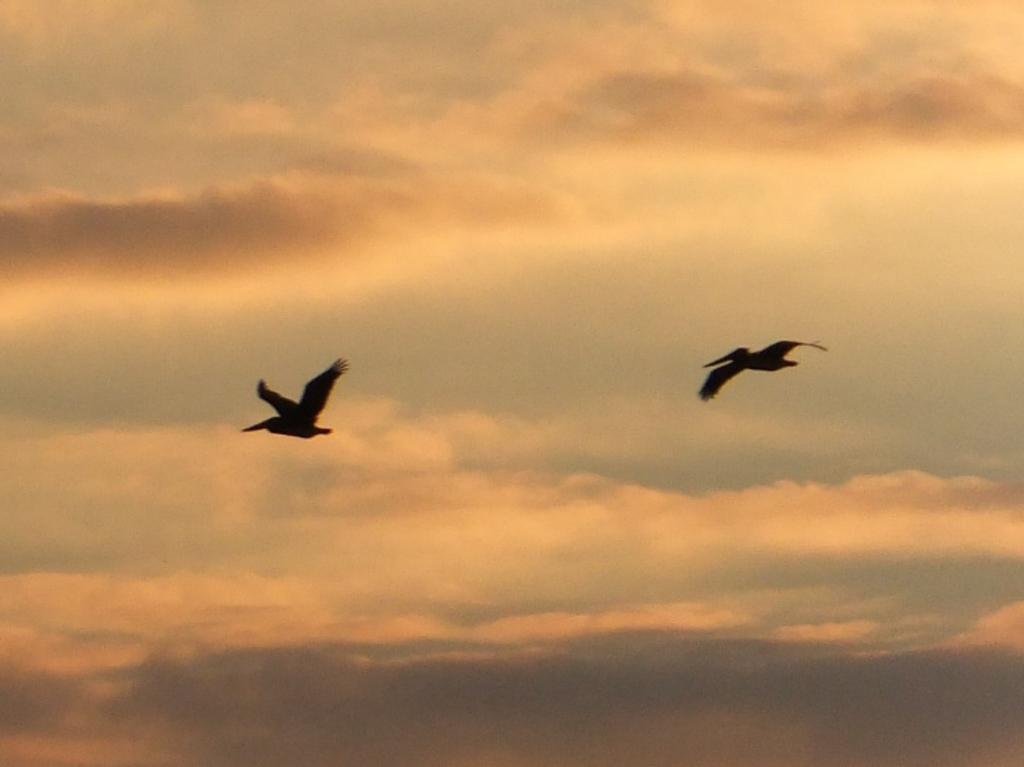Can you describe this image briefly? In this picture I can see two birds flying in the air, and in the background there is the sky. 